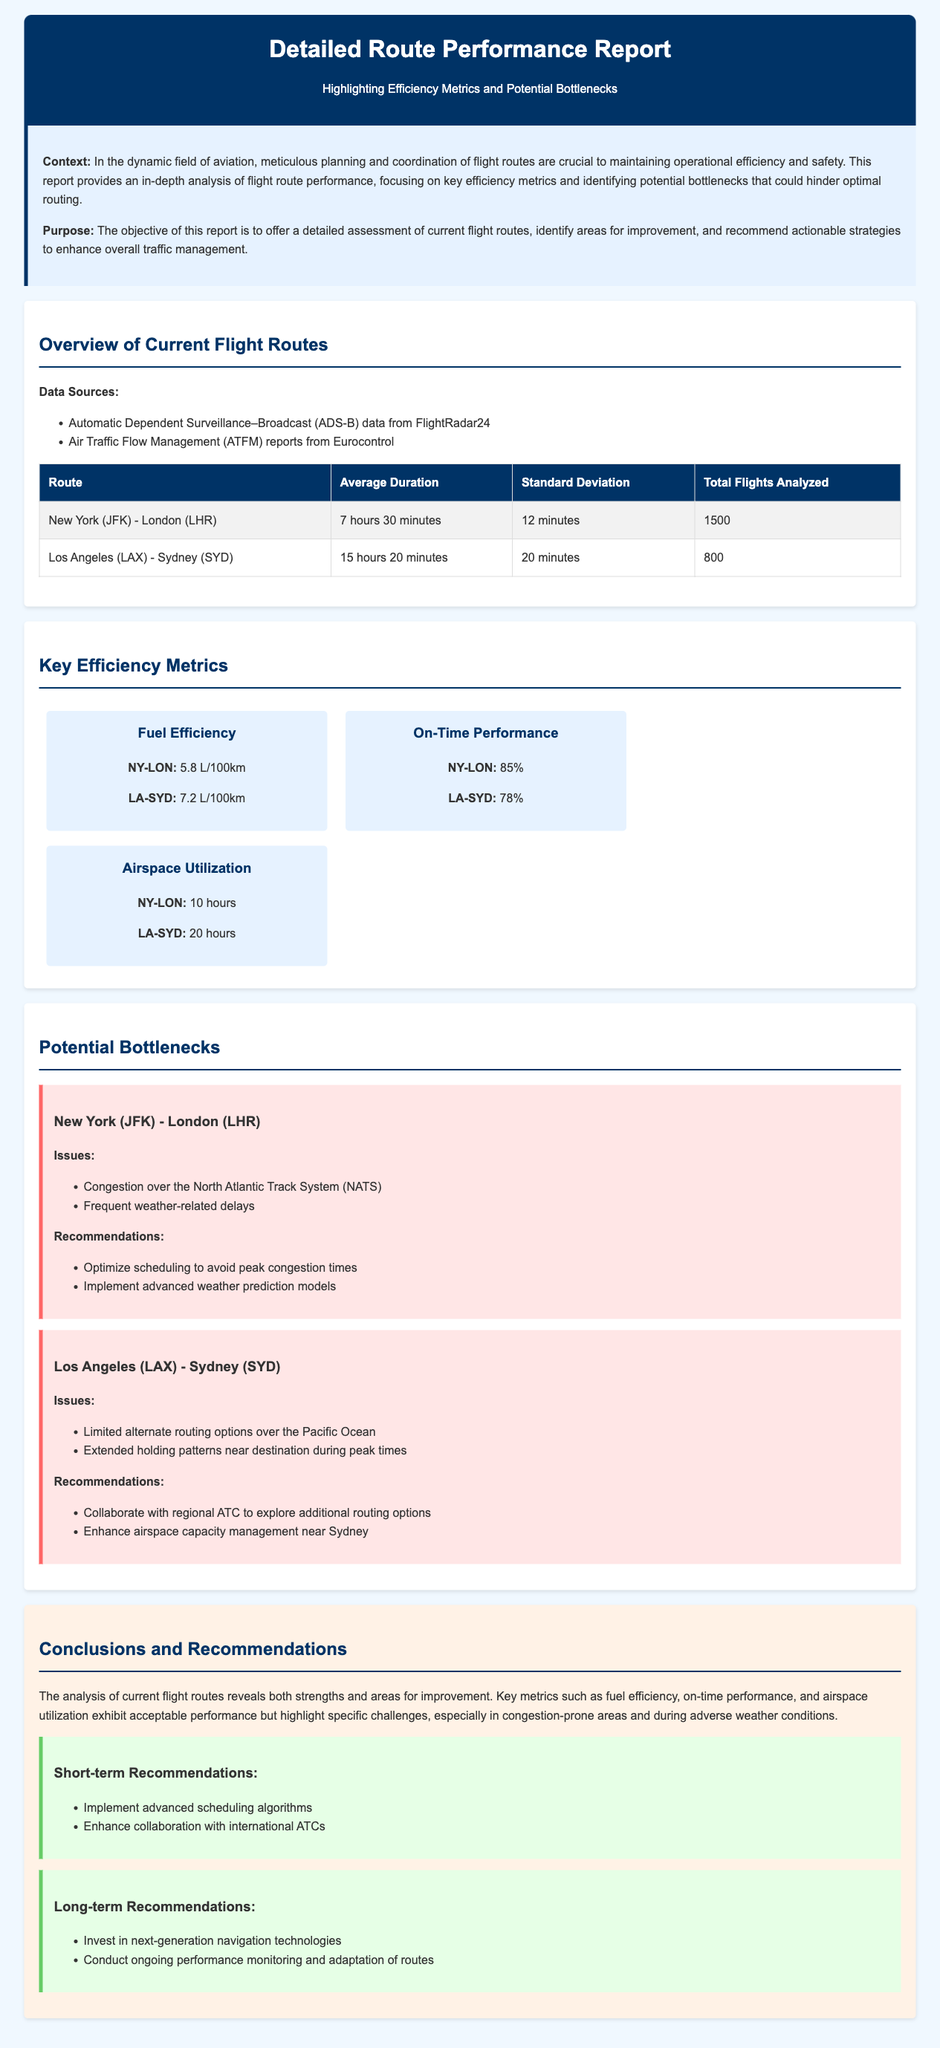What is the average duration for the New York to London route? The average duration for the New York to London route is listed as 7 hours 30 minutes in the document.
Answer: 7 hours 30 minutes What is the fuel efficiency for the Los Angeles to Sydney route? The fuel efficiency for the Los Angeles to Sydney route is provided as 7.2 L/100km.
Answer: 7.2 L/100km What are the two main issues affecting the New York to London route? The document lists congestion over the North Atlantic Track System and frequent weather-related delays as the main issues for the New York to London route.
Answer: Congestion, weather-related delays What percentage is the on-time performance for the New York to London route? The on-time performance for the New York to London route is stated as 85%.
Answer: 85% What is one recommendation for improving the Los Angeles to Sydney route? The document recommends collaborating with regional ATC to explore additional routing options for the Los Angeles to Sydney route.
Answer: Collaborate with regional ATC How many total flights were analyzed for the Los Angeles to Sydney route? The total flights analyzed for the Los Angeles to Sydney route is included as 800 in the document.
Answer: 800 What is the key issue for the Los Angeles to Sydney route? The document identifies limited alternate routing options over the Pacific Ocean as a key issue for this route.
Answer: Limited alternate routing options What kind of report is this document classified as? The document is classified as a Detailed Route Performance Report highlighting efficiency metrics and potential bottlenecks.
Answer: Detailed Route Performance Report What is the purpose of this report? The purpose of the report is to offer a detailed assessment of current flight routes and recommend strategies for enhancing overall traffic management.
Answer: Assessment and recommendations 